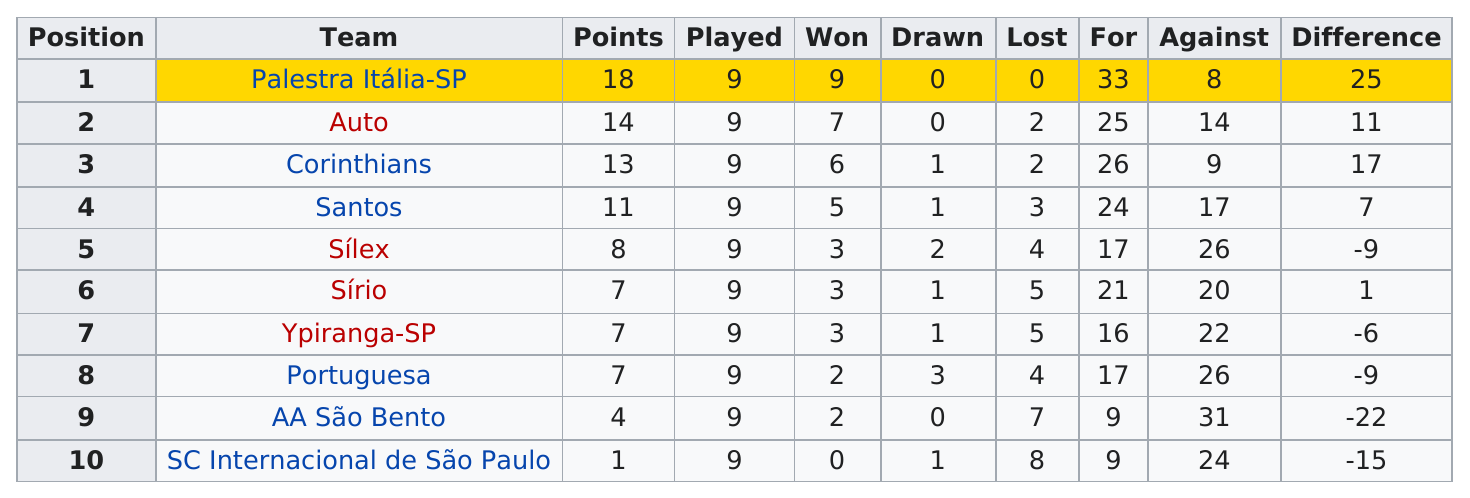Point out several critical features in this image. The Brazilian football team was able to earn 14 points in 1926. In 1926, the Brazilian football team SC Internacional de São Paulo received the fewest points out of all teams. In 1926, the Brazilian football league consisted of teams such as Palestra Itália-SP, Auto, and AA São Bento, which did not have any draws in their matches. There were a total of 90 games played per team. Both Ypiranga-SP and Portuguesa football teams of Brazil received 7 points in the 1926 season. 